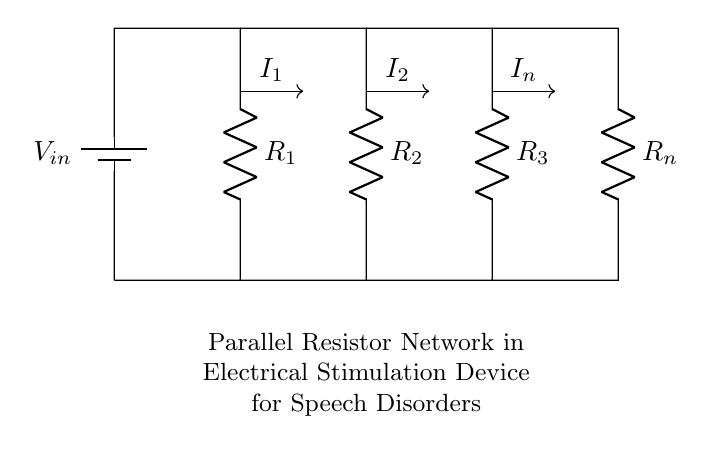What is the input voltage in this circuit? The input voltage is represented by the variable V_in, indicating the potential difference supplied to the circuit from the battery.
Answer: V_in How many resistors are in parallel in this network? There are four resistors labeled R_1, R_2, R_3, and R_n connected in parallel between the same two nodes, allowing current to flow through each path.
Answer: Four What is the current through resistor R_2? The current through R_2 is labeled as I_2, which represents the portion of the total current that flows specifically through this resistor due to the parallel arrangement.
Answer: I_2 What type of circuit configuration is used for R_1, R_2, R_3, and R_n? The resistors R_1, R_2, R_3, and R_n are arranged in a parallel configuration which allows the current to split, providing multiple paths for the current based on the respective resistances.
Answer: Parallel What determines the individual currents I_1, I_2, and I_n in this circuit? The individual currents I_1, I_2, and I_n are determined by the individual resistances of R_1, R_2, and R_n according to Ohm's Law, where current is inversely proportional to resistance in a parallel circuit.
Answer: Resistor values 